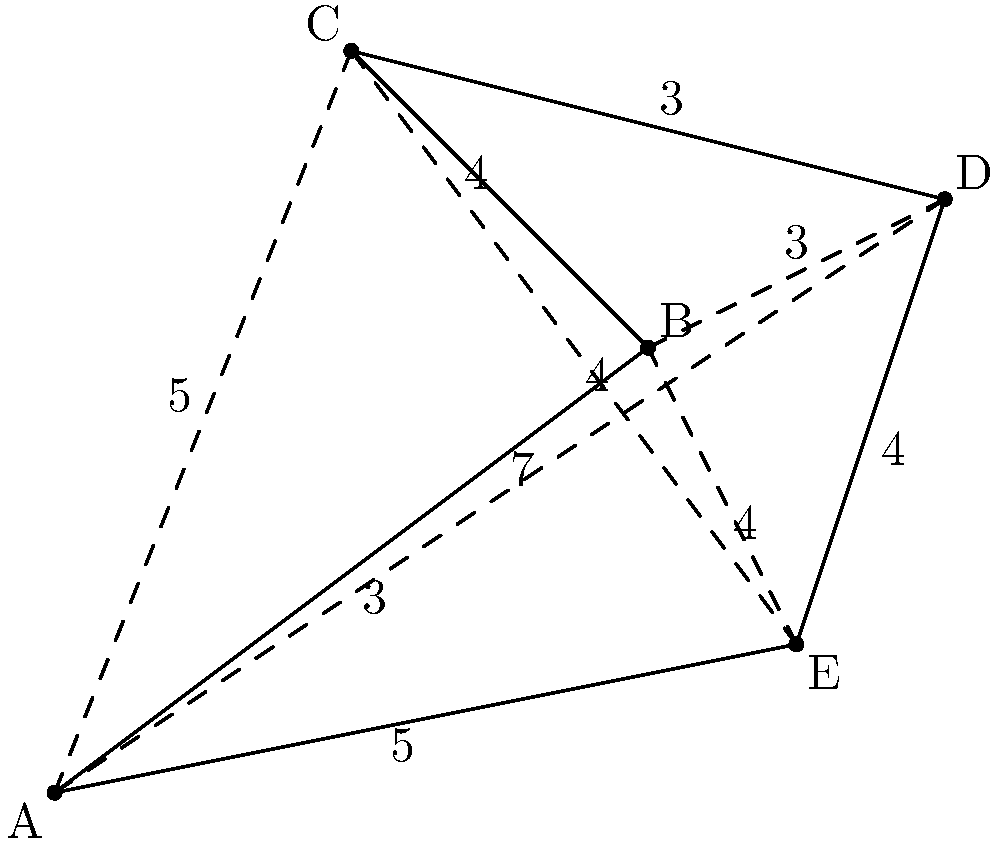Given the map with 5 waypoints (A, B, C, D, E) and their interconnecting routes, what is the shortest possible route that visits all waypoints exactly once and returns to the starting point? Provide the route and its total distance. To solve this problem, we need to use the Traveling Salesman Problem (TSP) approach. Since we have a small number of waypoints, we can use a brute-force method to find the optimal solution.

Steps:
1. List all possible permutations of the 5 waypoints (excluding the starting point, which will be the same as the ending point).
2. Calculate the total distance for each permutation.
3. Select the permutation with the shortest total distance.

Permutations (starting and ending at A):
1. A-B-C-D-E-A
2. A-B-C-E-D-A
3. A-B-D-C-E-A
4. A-B-D-E-C-A
5. A-B-E-C-D-A
6. A-B-E-D-C-A
7. A-C-B-D-E-A
8. A-C-B-E-D-A
9. A-C-D-B-E-A
10. A-C-D-E-B-A
11. A-C-E-B-D-A
12. A-C-E-D-B-A

Calculating distances for each permutation:
1. A-B-C-D-E-A = 3 + 4 + 3 + 4 + 5 = 19
2. A-B-C-E-D-A = 3 + 4 + 4 + 4 + 7 = 22
3. A-B-D-C-E-A = 3 + 3 + 3 + 4 + 5 = 18
4. A-B-D-E-C-A = 3 + 3 + 4 + 4 + 5 = 19
5. A-B-E-C-D-A = 3 + 4 + 4 + 3 + 7 = 21
6. A-B-E-D-C-A = 3 + 4 + 4 + 3 + 5 = 19
7. A-C-B-D-E-A = 5 + 4 + 3 + 4 + 5 = 21
8. A-C-B-E-D-A = 5 + 4 + 4 + 4 + 7 = 24
9. A-C-D-B-E-A = 5 + 3 + 3 + 4 + 5 = 20
10. A-C-D-E-B-A = 5 + 3 + 4 + 4 + 3 = 19
11. A-C-E-B-D-A = 5 + 4 + 4 + 3 + 7 = 23
12. A-C-E-D-B-A = 5 + 4 + 4 + 3 + 3 = 19

The shortest route is A-B-D-C-E-A with a total distance of 18.
Answer: A-B-D-C-E-A, 18 